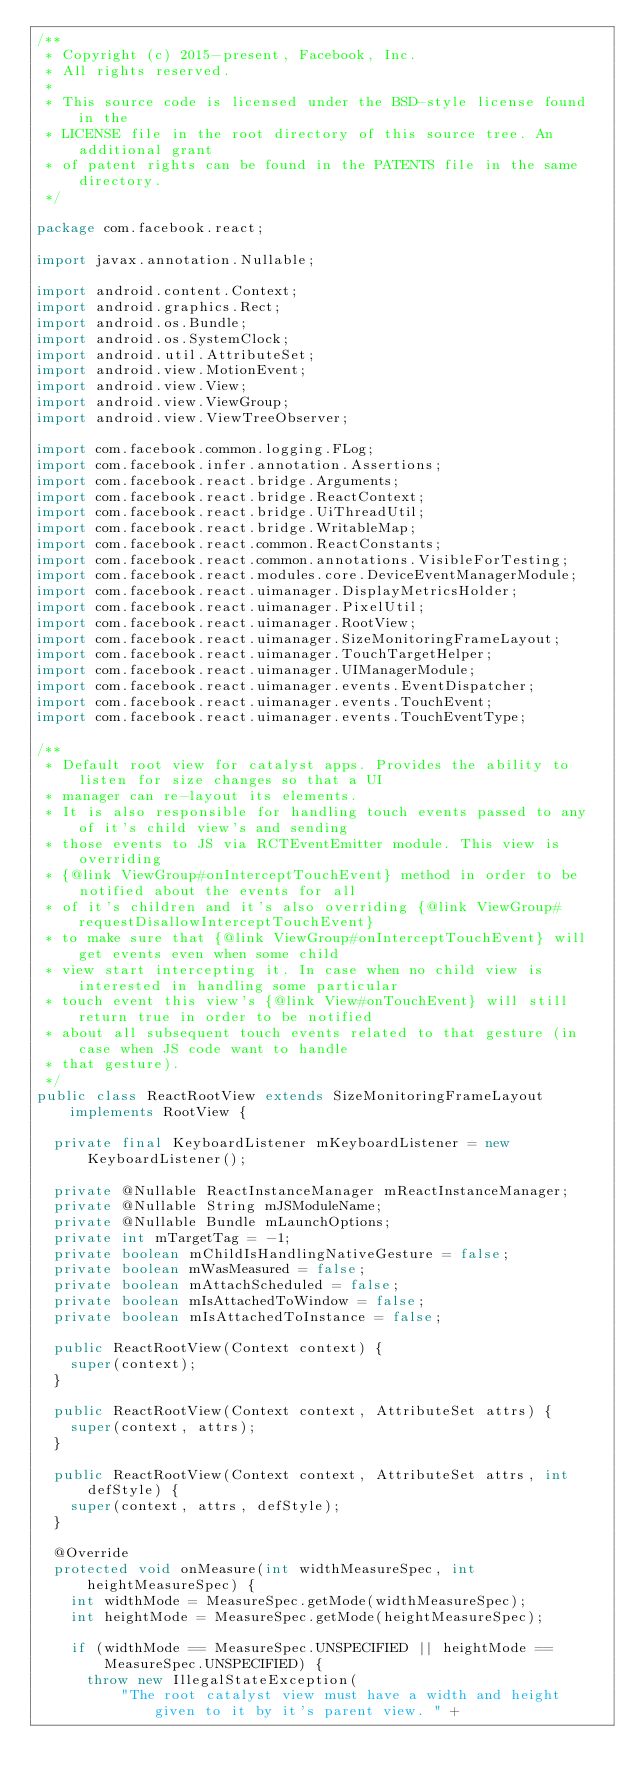<code> <loc_0><loc_0><loc_500><loc_500><_Java_>/**
 * Copyright (c) 2015-present, Facebook, Inc.
 * All rights reserved.
 *
 * This source code is licensed under the BSD-style license found in the
 * LICENSE file in the root directory of this source tree. An additional grant
 * of patent rights can be found in the PATENTS file in the same directory.
 */

package com.facebook.react;

import javax.annotation.Nullable;

import android.content.Context;
import android.graphics.Rect;
import android.os.Bundle;
import android.os.SystemClock;
import android.util.AttributeSet;
import android.view.MotionEvent;
import android.view.View;
import android.view.ViewGroup;
import android.view.ViewTreeObserver;

import com.facebook.common.logging.FLog;
import com.facebook.infer.annotation.Assertions;
import com.facebook.react.bridge.Arguments;
import com.facebook.react.bridge.ReactContext;
import com.facebook.react.bridge.UiThreadUtil;
import com.facebook.react.bridge.WritableMap;
import com.facebook.react.common.ReactConstants;
import com.facebook.react.common.annotations.VisibleForTesting;
import com.facebook.react.modules.core.DeviceEventManagerModule;
import com.facebook.react.uimanager.DisplayMetricsHolder;
import com.facebook.react.uimanager.PixelUtil;
import com.facebook.react.uimanager.RootView;
import com.facebook.react.uimanager.SizeMonitoringFrameLayout;
import com.facebook.react.uimanager.TouchTargetHelper;
import com.facebook.react.uimanager.UIManagerModule;
import com.facebook.react.uimanager.events.EventDispatcher;
import com.facebook.react.uimanager.events.TouchEvent;
import com.facebook.react.uimanager.events.TouchEventType;

/**
 * Default root view for catalyst apps. Provides the ability to listen for size changes so that a UI
 * manager can re-layout its elements.
 * It is also responsible for handling touch events passed to any of it's child view's and sending
 * those events to JS via RCTEventEmitter module. This view is overriding
 * {@link ViewGroup#onInterceptTouchEvent} method in order to be notified about the events for all
 * of it's children and it's also overriding {@link ViewGroup#requestDisallowInterceptTouchEvent}
 * to make sure that {@link ViewGroup#onInterceptTouchEvent} will get events even when some child
 * view start intercepting it. In case when no child view is interested in handling some particular
 * touch event this view's {@link View#onTouchEvent} will still return true in order to be notified
 * about all subsequent touch events related to that gesture (in case when JS code want to handle
 * that gesture).
 */
public class ReactRootView extends SizeMonitoringFrameLayout implements RootView {

  private final KeyboardListener mKeyboardListener = new KeyboardListener();

  private @Nullable ReactInstanceManager mReactInstanceManager;
  private @Nullable String mJSModuleName;
  private @Nullable Bundle mLaunchOptions;
  private int mTargetTag = -1;
  private boolean mChildIsHandlingNativeGesture = false;
  private boolean mWasMeasured = false;
  private boolean mAttachScheduled = false;
  private boolean mIsAttachedToWindow = false;
  private boolean mIsAttachedToInstance = false;

  public ReactRootView(Context context) {
    super(context);
  }

  public ReactRootView(Context context, AttributeSet attrs) {
    super(context, attrs);
  }

  public ReactRootView(Context context, AttributeSet attrs, int defStyle) {
    super(context, attrs, defStyle);
  }

  @Override
  protected void onMeasure(int widthMeasureSpec, int heightMeasureSpec) {
    int widthMode = MeasureSpec.getMode(widthMeasureSpec);
    int heightMode = MeasureSpec.getMode(heightMeasureSpec);

    if (widthMode == MeasureSpec.UNSPECIFIED || heightMode == MeasureSpec.UNSPECIFIED) {
      throw new IllegalStateException(
          "The root catalyst view must have a width and height given to it by it's parent view. " +</code> 